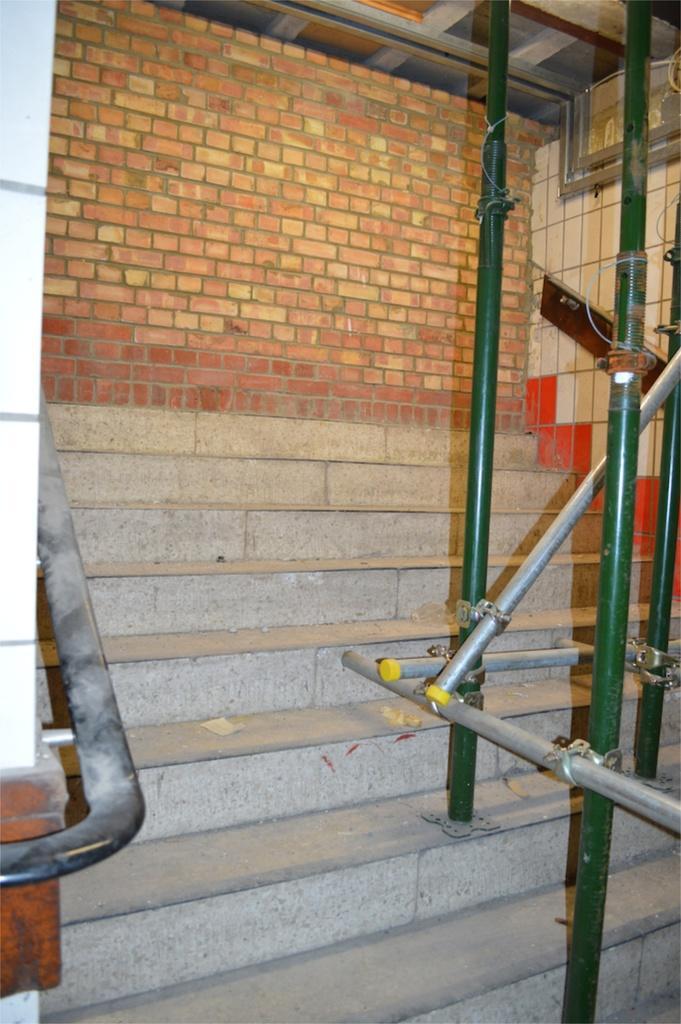In one or two sentences, can you explain what this image depicts? In this picture I can see stairs and a brick wall in the back and I can see few metal rods. 